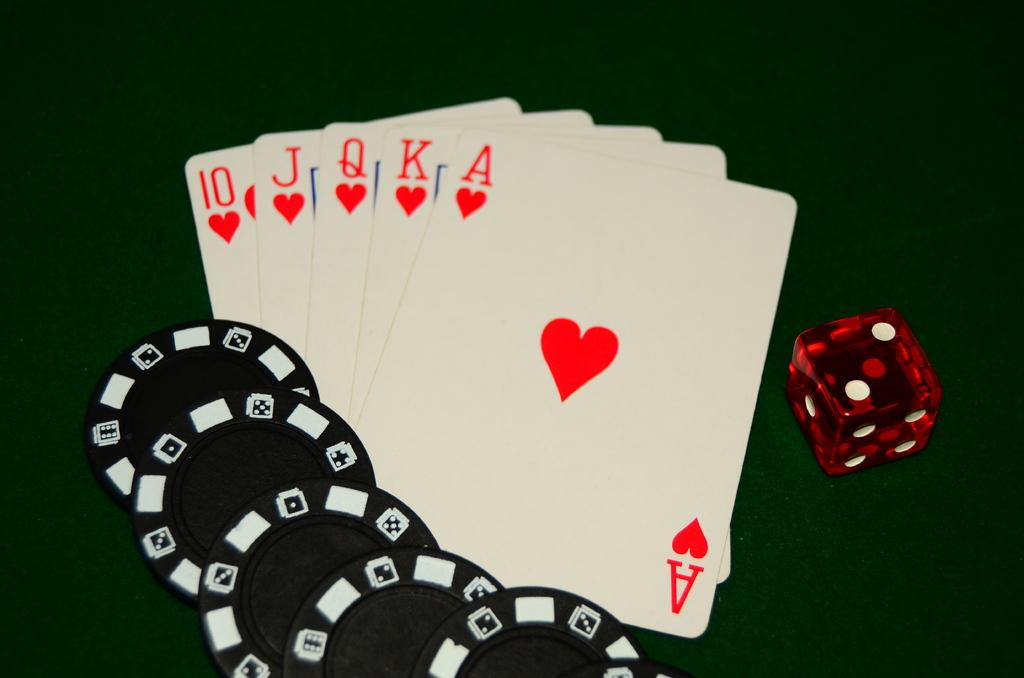Provide a one-sentence caption for the provided image. Five black poker chips, a red die, and five playing cards showing a royal flush are all next to each other. 